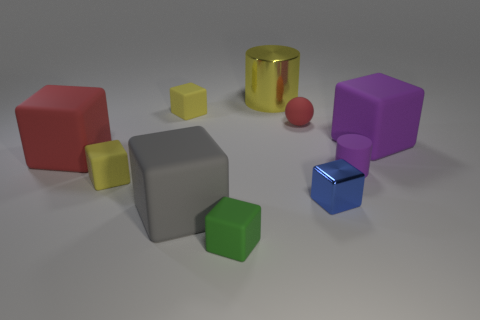The big cube that is behind the rubber cylinder and in front of the big purple thing is made of what material?
Provide a short and direct response. Rubber. What size is the green block?
Provide a succinct answer. Small. What number of cubes are small metallic things or big shiny objects?
Make the answer very short. 1. What is the size of the other thing that is the same shape as the tiny purple matte thing?
Give a very brief answer. Large. How many large yellow rubber objects are there?
Your answer should be very brief. 0. There is a big red thing; is its shape the same as the yellow thing that is in front of the purple cylinder?
Ensure brevity in your answer.  Yes. How big is the cylinder on the right side of the blue object?
Ensure brevity in your answer.  Small. What material is the gray thing?
Offer a terse response. Rubber. There is a large rubber object that is to the right of the big yellow thing; does it have the same shape as the green thing?
Make the answer very short. Yes. The object that is the same color as the tiny matte ball is what size?
Offer a terse response. Large. 